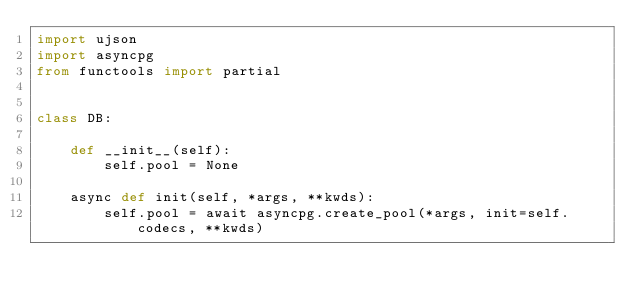Convert code to text. <code><loc_0><loc_0><loc_500><loc_500><_Python_>import ujson
import asyncpg
from functools import partial


class DB:

    def __init__(self):
        self.pool = None

    async def init(self, *args, **kwds):
        self.pool = await asyncpg.create_pool(*args, init=self.codecs, **kwds)
</code> 